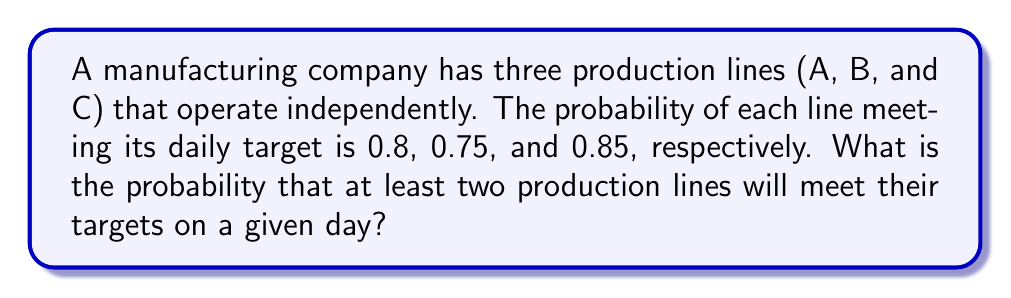Solve this math problem. Let's approach this step-by-step:

1) First, we need to calculate the probability of each possible outcome where at least two lines meet their targets. The possible scenarios are:
   - All three lines meet their targets
   - Only lines A and B meet their targets
   - Only lines A and C meet their targets
   - Only lines B and C meet their targets

2) Let's calculate each scenario:

   a) All three lines meet their targets:
      $P(\text{A and B and C}) = 0.8 \times 0.75 \times 0.85 = 0.51$

   b) Only A and B meet their targets:
      $P(\text{A and B, not C}) = 0.8 \times 0.75 \times (1 - 0.85) = 0.09$

   c) Only A and C meet their targets:
      $P(\text{A and C, not B}) = 0.8 \times (1 - 0.75) \times 0.85 = 0.17$

   d) Only B and C meet their targets:
      $P(\text{B and C, not A}) = (1 - 0.8) \times 0.75 \times 0.85 = 0.1275$

3) The total probability is the sum of all these scenarios:

   $P(\text{at least two}) = 0.51 + 0.09 + 0.17 + 0.1275 = 0.8975$

Therefore, the probability that at least two production lines will meet their targets on a given day is 0.8975 or 89.75%.
Answer: 0.8975 